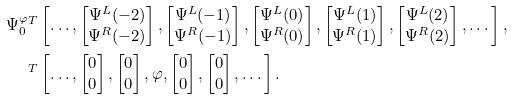<formula> <loc_0><loc_0><loc_500><loc_500>\Psi _ { 0 } ^ { \varphi } & ^ { T } \left [ \dots , \begin{bmatrix} \Psi ^ { L } ( - 2 ) \\ \Psi ^ { R } ( - 2 ) \end{bmatrix} , \begin{bmatrix} \Psi ^ { L } ( - 1 ) \\ \Psi ^ { R } ( - 1 ) \end{bmatrix} , \begin{bmatrix} \Psi ^ { L } ( 0 ) \\ \Psi ^ { R } ( 0 ) \end{bmatrix} , \begin{bmatrix} \Psi ^ { L } ( 1 ) \\ \Psi ^ { R } ( 1 ) \end{bmatrix} , \begin{bmatrix} \Psi ^ { L } ( 2 ) \\ \Psi ^ { R } ( 2 ) \end{bmatrix} , \dots \right ] , \\ & ^ { T } \left [ \dots , \begin{bmatrix} 0 \\ 0 \end{bmatrix} , \begin{bmatrix} 0 \\ 0 \end{bmatrix} , \varphi , \begin{bmatrix} 0 \\ 0 \end{bmatrix} , \begin{bmatrix} 0 \\ 0 \end{bmatrix} , \dots \right ] .</formula> 